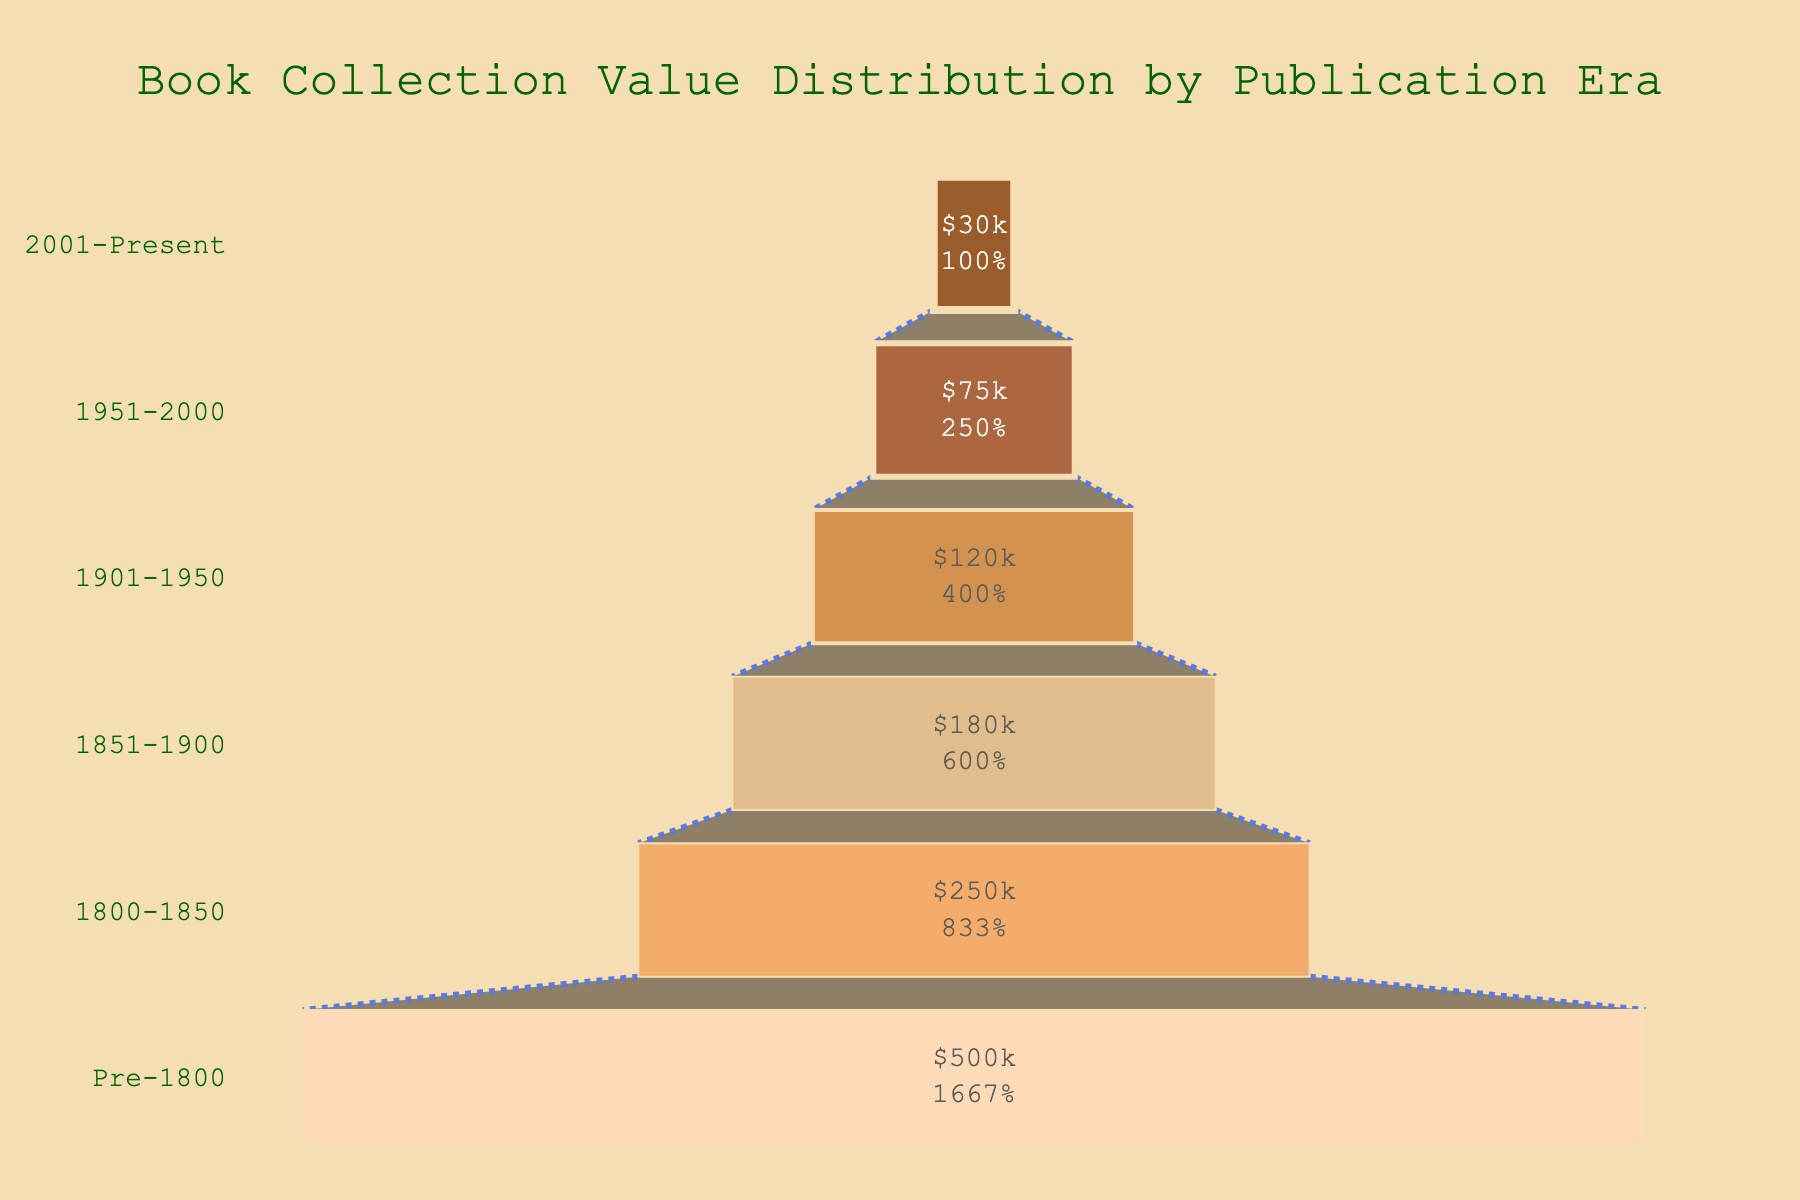What is the title of the chart? The title of the chart is shown at the top of the funnel chart visual. It indicates the primary focus of the plot.
Answer: Book Collection Value Distribution by Publication Era How many publication eras are represented in the chart? By counting the unique segments in the funnel, which represent different publication eras, we can determine the number of eras displayed.
Answer: 6 What is the value for books published in the era 1851-1900? Look at the segment labeled "1851-1900" in the funnel chart, and read the value inside the segment.
Answer: $180,000 Which era has the highest book collection value? The era with the widest segment at the top of the funnel is the one with the highest value.
Answer: Pre-1800 How does the value for books from 1901-1950 compare to the value for books from 2001-Present? Compare the width of the "1901-1950" segment to the "2001-Present" segment and see which one is wider.
Answer: 1901-1950 has a higher value What is the total value of the book collection for all eras? Sum the values displayed inside all segments of the funnel: $500,000 + $250,000 + $180,000 + $120,000 + $75,000 + $30,000.
Answer: $1,155,000 What percentage of the total value is attributed to books from the era 1800-1850? Calculate the percentage by dividing the value of the era by the total value and then multiplying by 100: (250,000 / 1,155,000) * 100.
Answer: ~21.65% What is the difference in value between books from the era Pre-1800 and books from 1951-2000? Subtract the value of the latter era from the value of the former era: $500,000 - $75,000.
Answer: $425,000 Which era saw the steepest decrease in book collection value from the previous era? Observe the changes in segment widths from one era to the following one and identify where the drop is steepest.
Answer: 1951-2000 If converting the value of books from the 1800-1850 era into percentages of the total collection value, what portion would each USD value of that era contribute per $1 of total value? Compute the ratio of the era's value to the total value simply: 250,000 / 1,155,000.
Answer: ~0.2165 per $1 